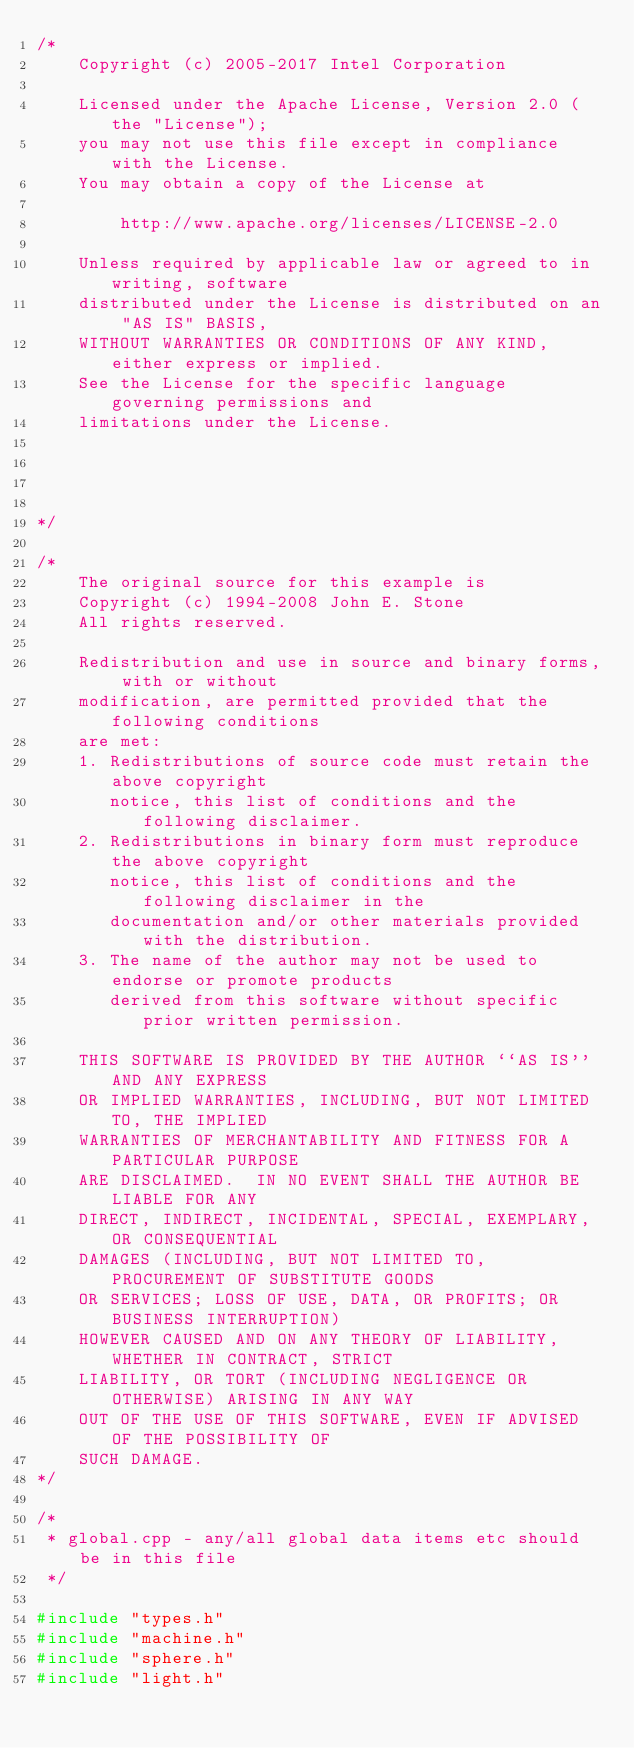Convert code to text. <code><loc_0><loc_0><loc_500><loc_500><_C++_>/*
    Copyright (c) 2005-2017 Intel Corporation

    Licensed under the Apache License, Version 2.0 (the "License");
    you may not use this file except in compliance with the License.
    You may obtain a copy of the License at

        http://www.apache.org/licenses/LICENSE-2.0

    Unless required by applicable law or agreed to in writing, software
    distributed under the License is distributed on an "AS IS" BASIS,
    WITHOUT WARRANTIES OR CONDITIONS OF ANY KIND, either express or implied.
    See the License for the specific language governing permissions and
    limitations under the License.




*/

/*
    The original source for this example is
    Copyright (c) 1994-2008 John E. Stone
    All rights reserved.

    Redistribution and use in source and binary forms, with or without
    modification, are permitted provided that the following conditions
    are met:
    1. Redistributions of source code must retain the above copyright
       notice, this list of conditions and the following disclaimer.
    2. Redistributions in binary form must reproduce the above copyright
       notice, this list of conditions and the following disclaimer in the
       documentation and/or other materials provided with the distribution.
    3. The name of the author may not be used to endorse or promote products
       derived from this software without specific prior written permission.

    THIS SOFTWARE IS PROVIDED BY THE AUTHOR ``AS IS'' AND ANY EXPRESS
    OR IMPLIED WARRANTIES, INCLUDING, BUT NOT LIMITED TO, THE IMPLIED
    WARRANTIES OF MERCHANTABILITY AND FITNESS FOR A PARTICULAR PURPOSE
    ARE DISCLAIMED.  IN NO EVENT SHALL THE AUTHOR BE LIABLE FOR ANY
    DIRECT, INDIRECT, INCIDENTAL, SPECIAL, EXEMPLARY, OR CONSEQUENTIAL
    DAMAGES (INCLUDING, BUT NOT LIMITED TO, PROCUREMENT OF SUBSTITUTE GOODS
    OR SERVICES; LOSS OF USE, DATA, OR PROFITS; OR BUSINESS INTERRUPTION)
    HOWEVER CAUSED AND ON ANY THEORY OF LIABILITY, WHETHER IN CONTRACT, STRICT
    LIABILITY, OR TORT (INCLUDING NEGLIGENCE OR OTHERWISE) ARISING IN ANY WAY
    OUT OF THE USE OF THIS SOFTWARE, EVEN IF ADVISED OF THE POSSIBILITY OF
    SUCH DAMAGE.
*/

/*
 * global.cpp - any/all global data items etc should be in this file
 */

#include "types.h"
#include "machine.h"
#include "sphere.h"
#include "light.h"
</code> 